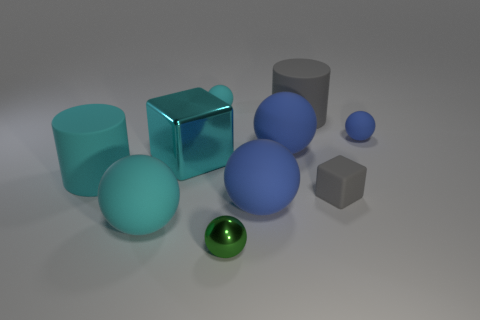There is another object that is the same shape as the large cyan metallic object; what material is it?
Your answer should be compact. Rubber. There is a cube that is left of the small thing that is in front of the cyan ball that is in front of the tiny cyan sphere; what is its material?
Offer a terse response. Metal. The green sphere that is made of the same material as the cyan block is what size?
Provide a short and direct response. Small. Is there anything else that is the same color as the small matte block?
Give a very brief answer. Yes. There is a matte object on the right side of the small gray rubber block; is its color the same as the shiny thing that is right of the big block?
Your answer should be compact. No. There is a cylinder on the left side of the tiny cyan matte object; what is its color?
Make the answer very short. Cyan. Do the cylinder that is right of the green metal sphere and the tiny shiny thing have the same size?
Offer a very short reply. No. Are there fewer large blue matte spheres than tiny gray cubes?
Your response must be concise. No. There is a large thing that is the same color as the small cube; what shape is it?
Make the answer very short. Cylinder. There is a gray rubber block; how many small matte objects are to the right of it?
Give a very brief answer. 1. 